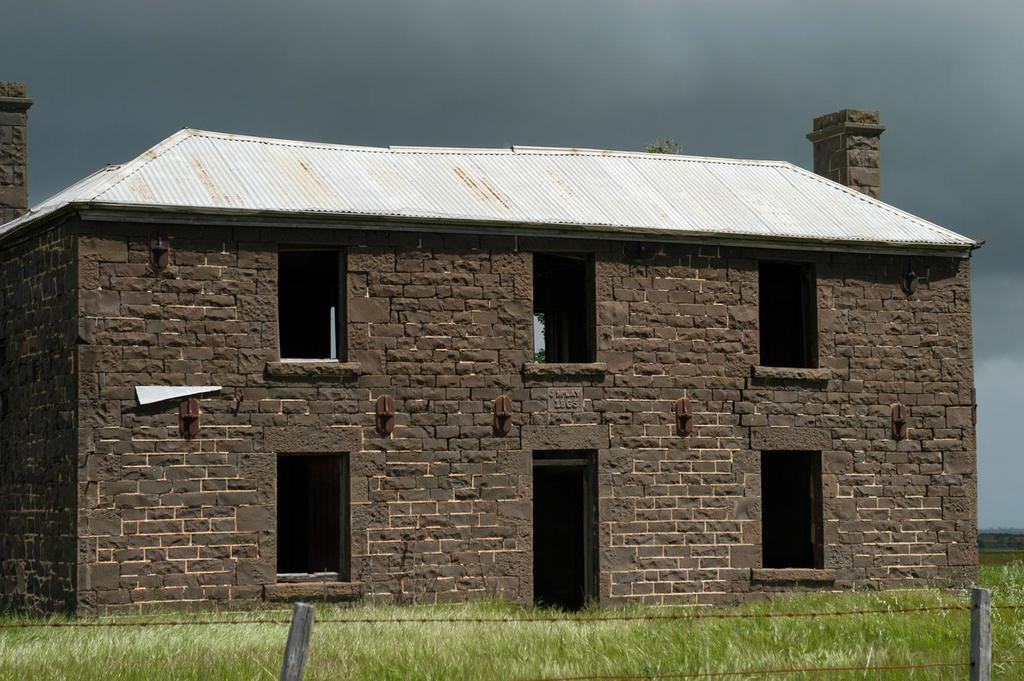What type of structure is present in the image? There is a house in the picture. What type of vegetation can be seen in the image? There is grass in the picture. What type of barrier is present in the image? There is a fence in the picture. What is visible in the background of the image? The sky is visible in the background of the picture. What type of humor can be seen in the jellyfish in the image? There are no jellyfish present in the image, so it is not possible to determine the type of humor they might exhibit. 